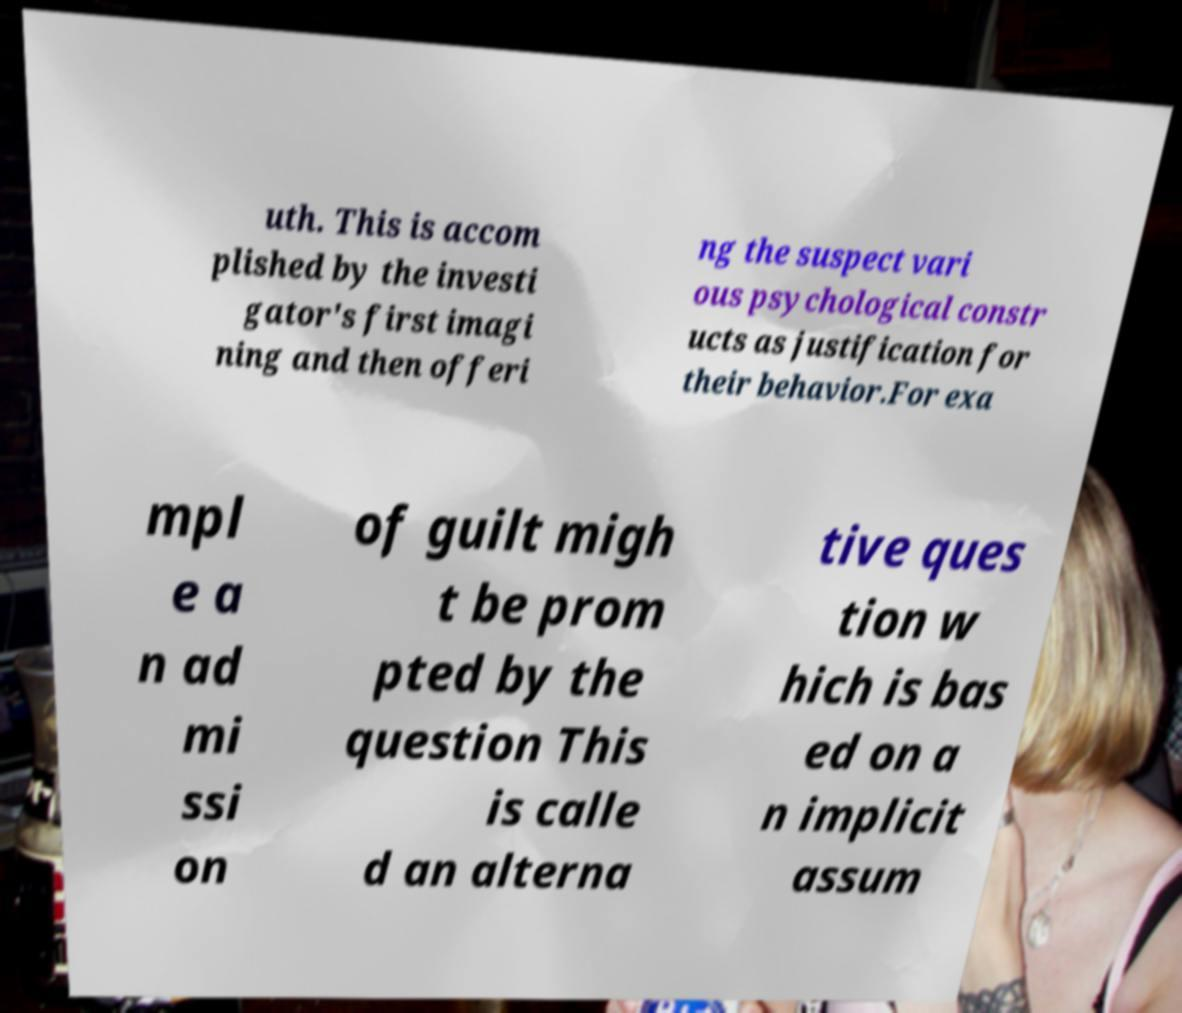Could you assist in decoding the text presented in this image and type it out clearly? uth. This is accom plished by the investi gator's first imagi ning and then offeri ng the suspect vari ous psychological constr ucts as justification for their behavior.For exa mpl e a n ad mi ssi on of guilt migh t be prom pted by the question This is calle d an alterna tive ques tion w hich is bas ed on a n implicit assum 